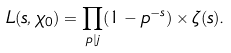<formula> <loc_0><loc_0><loc_500><loc_500>L ( s , \chi _ { 0 } ) = \prod _ { p | j } ( 1 - p ^ { - s } ) \times \zeta ( s ) .</formula> 